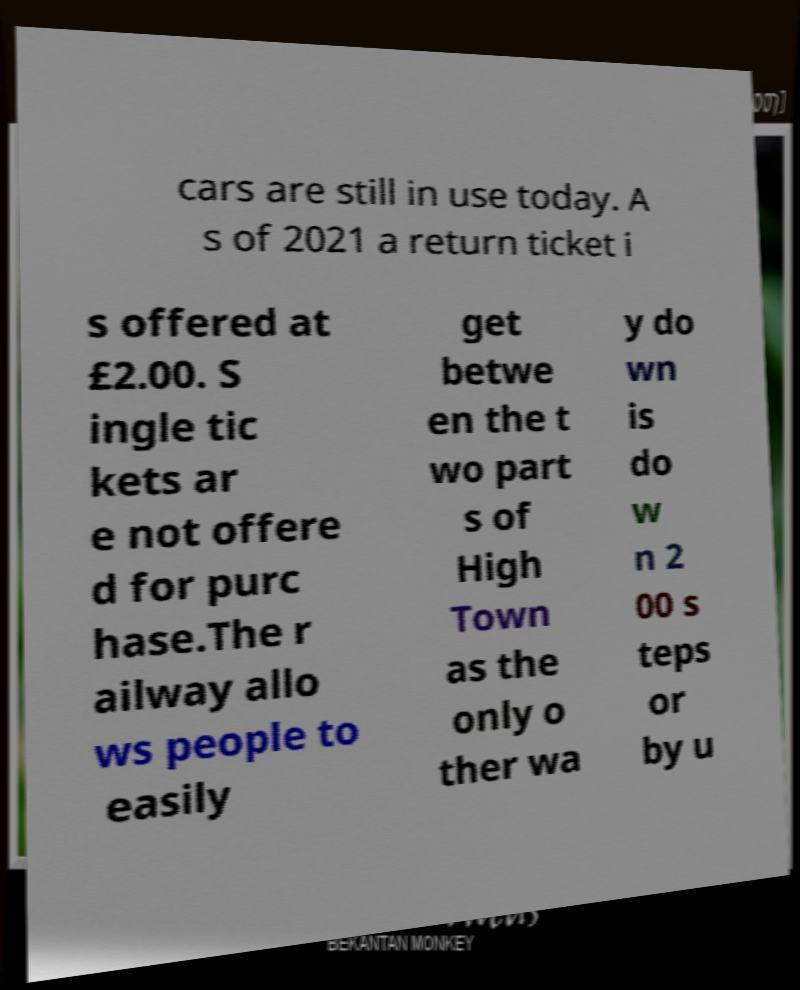Could you extract and type out the text from this image? cars are still in use today. A s of 2021 a return ticket i s offered at £2.00. S ingle tic kets ar e not offere d for purc hase.The r ailway allo ws people to easily get betwe en the t wo part s of High Town as the only o ther wa y do wn is do w n 2 00 s teps or by u 